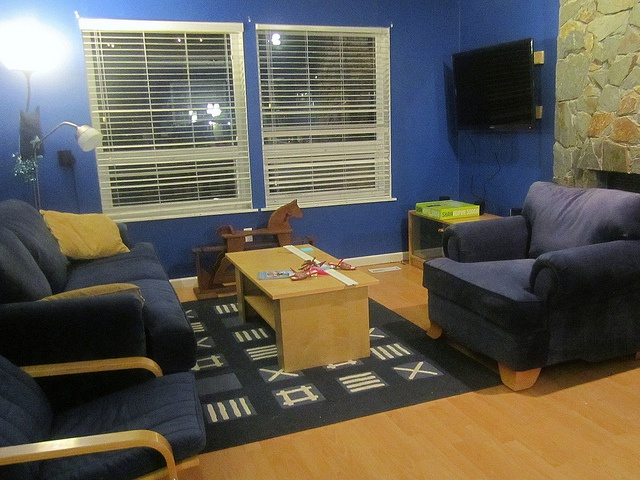Describe the objects in this image and their specific colors. I can see chair in lightblue, black, and gray tones, couch in lightblue, black, gray, and tan tones, chair in lightblue, black, and olive tones, and tv in lightblue, black, navy, and olive tones in this image. 